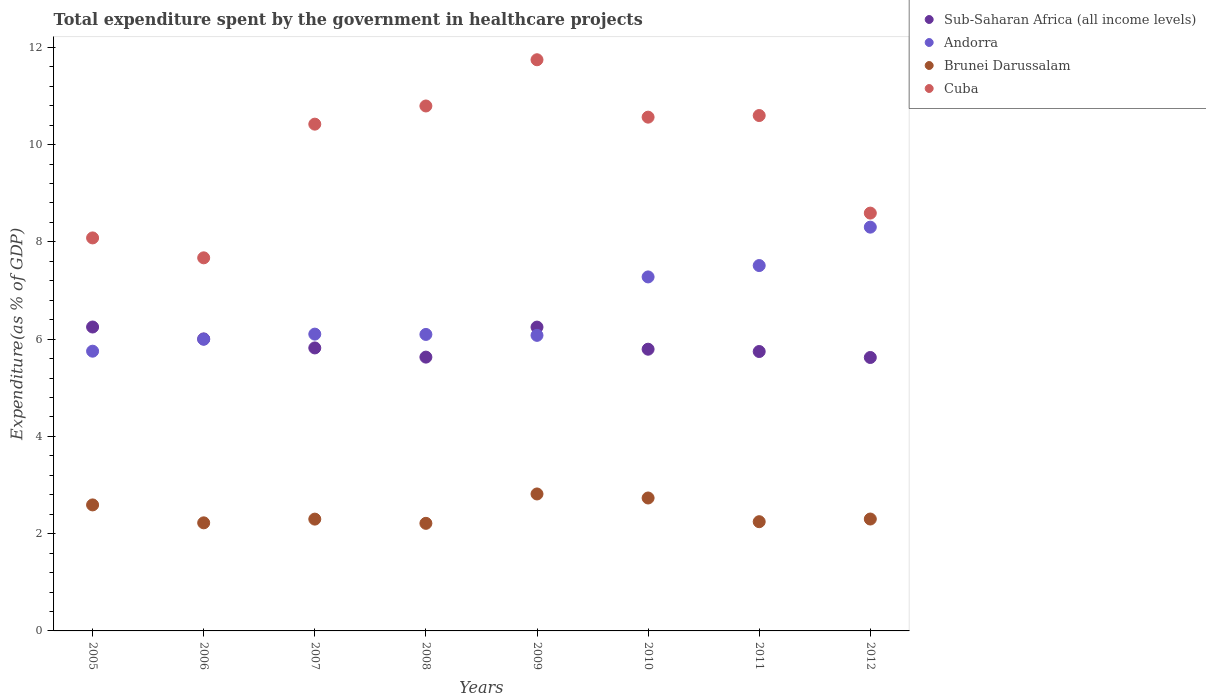How many different coloured dotlines are there?
Offer a very short reply. 4. What is the total expenditure spent by the government in healthcare projects in Brunei Darussalam in 2005?
Ensure brevity in your answer.  2.59. Across all years, what is the maximum total expenditure spent by the government in healthcare projects in Cuba?
Provide a succinct answer. 11.74. Across all years, what is the minimum total expenditure spent by the government in healthcare projects in Brunei Darussalam?
Your answer should be very brief. 2.21. In which year was the total expenditure spent by the government in healthcare projects in Cuba minimum?
Your answer should be compact. 2006. What is the total total expenditure spent by the government in healthcare projects in Cuba in the graph?
Your answer should be compact. 78.46. What is the difference between the total expenditure spent by the government in healthcare projects in Brunei Darussalam in 2007 and that in 2010?
Provide a succinct answer. -0.43. What is the difference between the total expenditure spent by the government in healthcare projects in Cuba in 2011 and the total expenditure spent by the government in healthcare projects in Sub-Saharan Africa (all income levels) in 2010?
Ensure brevity in your answer.  4.8. What is the average total expenditure spent by the government in healthcare projects in Brunei Darussalam per year?
Offer a terse response. 2.43. In the year 2006, what is the difference between the total expenditure spent by the government in healthcare projects in Sub-Saharan Africa (all income levels) and total expenditure spent by the government in healthcare projects in Brunei Darussalam?
Make the answer very short. 3.78. What is the ratio of the total expenditure spent by the government in healthcare projects in Andorra in 2005 to that in 2011?
Provide a succinct answer. 0.77. Is the difference between the total expenditure spent by the government in healthcare projects in Sub-Saharan Africa (all income levels) in 2005 and 2012 greater than the difference between the total expenditure spent by the government in healthcare projects in Brunei Darussalam in 2005 and 2012?
Ensure brevity in your answer.  Yes. What is the difference between the highest and the second highest total expenditure spent by the government in healthcare projects in Brunei Darussalam?
Your response must be concise. 0.08. What is the difference between the highest and the lowest total expenditure spent by the government in healthcare projects in Sub-Saharan Africa (all income levels)?
Your response must be concise. 0.63. Is it the case that in every year, the sum of the total expenditure spent by the government in healthcare projects in Andorra and total expenditure spent by the government in healthcare projects in Brunei Darussalam  is greater than the sum of total expenditure spent by the government in healthcare projects in Cuba and total expenditure spent by the government in healthcare projects in Sub-Saharan Africa (all income levels)?
Offer a very short reply. Yes. Is it the case that in every year, the sum of the total expenditure spent by the government in healthcare projects in Sub-Saharan Africa (all income levels) and total expenditure spent by the government in healthcare projects in Cuba  is greater than the total expenditure spent by the government in healthcare projects in Andorra?
Provide a short and direct response. Yes. Is the total expenditure spent by the government in healthcare projects in Andorra strictly greater than the total expenditure spent by the government in healthcare projects in Brunei Darussalam over the years?
Your answer should be very brief. Yes. How many dotlines are there?
Ensure brevity in your answer.  4. How many years are there in the graph?
Your answer should be very brief. 8. What is the difference between two consecutive major ticks on the Y-axis?
Give a very brief answer. 2. Are the values on the major ticks of Y-axis written in scientific E-notation?
Provide a succinct answer. No. Where does the legend appear in the graph?
Ensure brevity in your answer.  Top right. What is the title of the graph?
Provide a short and direct response. Total expenditure spent by the government in healthcare projects. What is the label or title of the Y-axis?
Provide a succinct answer. Expenditure(as % of GDP). What is the Expenditure(as % of GDP) of Sub-Saharan Africa (all income levels) in 2005?
Your answer should be compact. 6.25. What is the Expenditure(as % of GDP) of Andorra in 2005?
Keep it short and to the point. 5.75. What is the Expenditure(as % of GDP) in Brunei Darussalam in 2005?
Offer a very short reply. 2.59. What is the Expenditure(as % of GDP) of Cuba in 2005?
Provide a short and direct response. 8.08. What is the Expenditure(as % of GDP) in Sub-Saharan Africa (all income levels) in 2006?
Make the answer very short. 6. What is the Expenditure(as % of GDP) in Andorra in 2006?
Make the answer very short. 6. What is the Expenditure(as % of GDP) in Brunei Darussalam in 2006?
Offer a very short reply. 2.22. What is the Expenditure(as % of GDP) of Cuba in 2006?
Give a very brief answer. 7.67. What is the Expenditure(as % of GDP) in Sub-Saharan Africa (all income levels) in 2007?
Offer a terse response. 5.82. What is the Expenditure(as % of GDP) in Andorra in 2007?
Your response must be concise. 6.1. What is the Expenditure(as % of GDP) of Brunei Darussalam in 2007?
Give a very brief answer. 2.3. What is the Expenditure(as % of GDP) of Cuba in 2007?
Make the answer very short. 10.42. What is the Expenditure(as % of GDP) in Sub-Saharan Africa (all income levels) in 2008?
Ensure brevity in your answer.  5.63. What is the Expenditure(as % of GDP) of Andorra in 2008?
Keep it short and to the point. 6.1. What is the Expenditure(as % of GDP) in Brunei Darussalam in 2008?
Provide a short and direct response. 2.21. What is the Expenditure(as % of GDP) of Cuba in 2008?
Your answer should be compact. 10.79. What is the Expenditure(as % of GDP) of Sub-Saharan Africa (all income levels) in 2009?
Ensure brevity in your answer.  6.25. What is the Expenditure(as % of GDP) of Andorra in 2009?
Your answer should be compact. 6.08. What is the Expenditure(as % of GDP) of Brunei Darussalam in 2009?
Your answer should be compact. 2.82. What is the Expenditure(as % of GDP) of Cuba in 2009?
Your response must be concise. 11.74. What is the Expenditure(as % of GDP) of Sub-Saharan Africa (all income levels) in 2010?
Provide a succinct answer. 5.79. What is the Expenditure(as % of GDP) of Andorra in 2010?
Your answer should be compact. 7.28. What is the Expenditure(as % of GDP) of Brunei Darussalam in 2010?
Ensure brevity in your answer.  2.73. What is the Expenditure(as % of GDP) of Cuba in 2010?
Your answer should be very brief. 10.56. What is the Expenditure(as % of GDP) in Sub-Saharan Africa (all income levels) in 2011?
Offer a terse response. 5.74. What is the Expenditure(as % of GDP) of Andorra in 2011?
Your answer should be compact. 7.51. What is the Expenditure(as % of GDP) of Brunei Darussalam in 2011?
Provide a succinct answer. 2.25. What is the Expenditure(as % of GDP) in Cuba in 2011?
Your answer should be very brief. 10.6. What is the Expenditure(as % of GDP) of Sub-Saharan Africa (all income levels) in 2012?
Offer a very short reply. 5.62. What is the Expenditure(as % of GDP) of Andorra in 2012?
Keep it short and to the point. 8.3. What is the Expenditure(as % of GDP) in Brunei Darussalam in 2012?
Your answer should be compact. 2.3. What is the Expenditure(as % of GDP) in Cuba in 2012?
Provide a succinct answer. 8.59. Across all years, what is the maximum Expenditure(as % of GDP) in Sub-Saharan Africa (all income levels)?
Provide a succinct answer. 6.25. Across all years, what is the maximum Expenditure(as % of GDP) of Andorra?
Offer a terse response. 8.3. Across all years, what is the maximum Expenditure(as % of GDP) in Brunei Darussalam?
Make the answer very short. 2.82. Across all years, what is the maximum Expenditure(as % of GDP) of Cuba?
Make the answer very short. 11.74. Across all years, what is the minimum Expenditure(as % of GDP) in Sub-Saharan Africa (all income levels)?
Offer a very short reply. 5.62. Across all years, what is the minimum Expenditure(as % of GDP) of Andorra?
Your response must be concise. 5.75. Across all years, what is the minimum Expenditure(as % of GDP) of Brunei Darussalam?
Give a very brief answer. 2.21. Across all years, what is the minimum Expenditure(as % of GDP) in Cuba?
Keep it short and to the point. 7.67. What is the total Expenditure(as % of GDP) of Sub-Saharan Africa (all income levels) in the graph?
Your answer should be compact. 47.11. What is the total Expenditure(as % of GDP) of Andorra in the graph?
Give a very brief answer. 53.12. What is the total Expenditure(as % of GDP) of Brunei Darussalam in the graph?
Offer a very short reply. 19.42. What is the total Expenditure(as % of GDP) in Cuba in the graph?
Your answer should be compact. 78.46. What is the difference between the Expenditure(as % of GDP) in Sub-Saharan Africa (all income levels) in 2005 and that in 2006?
Ensure brevity in your answer.  0.24. What is the difference between the Expenditure(as % of GDP) in Andorra in 2005 and that in 2006?
Offer a very short reply. -0.25. What is the difference between the Expenditure(as % of GDP) in Brunei Darussalam in 2005 and that in 2006?
Your answer should be very brief. 0.37. What is the difference between the Expenditure(as % of GDP) of Cuba in 2005 and that in 2006?
Offer a very short reply. 0.41. What is the difference between the Expenditure(as % of GDP) in Sub-Saharan Africa (all income levels) in 2005 and that in 2007?
Your answer should be compact. 0.43. What is the difference between the Expenditure(as % of GDP) in Andorra in 2005 and that in 2007?
Make the answer very short. -0.35. What is the difference between the Expenditure(as % of GDP) of Brunei Darussalam in 2005 and that in 2007?
Make the answer very short. 0.29. What is the difference between the Expenditure(as % of GDP) in Cuba in 2005 and that in 2007?
Your answer should be compact. -2.34. What is the difference between the Expenditure(as % of GDP) in Sub-Saharan Africa (all income levels) in 2005 and that in 2008?
Your answer should be compact. 0.62. What is the difference between the Expenditure(as % of GDP) in Andorra in 2005 and that in 2008?
Ensure brevity in your answer.  -0.34. What is the difference between the Expenditure(as % of GDP) in Brunei Darussalam in 2005 and that in 2008?
Make the answer very short. 0.38. What is the difference between the Expenditure(as % of GDP) of Cuba in 2005 and that in 2008?
Make the answer very short. -2.71. What is the difference between the Expenditure(as % of GDP) of Sub-Saharan Africa (all income levels) in 2005 and that in 2009?
Offer a terse response. 0. What is the difference between the Expenditure(as % of GDP) in Andorra in 2005 and that in 2009?
Your answer should be very brief. -0.33. What is the difference between the Expenditure(as % of GDP) of Brunei Darussalam in 2005 and that in 2009?
Your answer should be compact. -0.23. What is the difference between the Expenditure(as % of GDP) of Cuba in 2005 and that in 2009?
Offer a terse response. -3.66. What is the difference between the Expenditure(as % of GDP) of Sub-Saharan Africa (all income levels) in 2005 and that in 2010?
Your answer should be compact. 0.46. What is the difference between the Expenditure(as % of GDP) of Andorra in 2005 and that in 2010?
Offer a very short reply. -1.53. What is the difference between the Expenditure(as % of GDP) in Brunei Darussalam in 2005 and that in 2010?
Offer a terse response. -0.14. What is the difference between the Expenditure(as % of GDP) of Cuba in 2005 and that in 2010?
Offer a terse response. -2.48. What is the difference between the Expenditure(as % of GDP) of Sub-Saharan Africa (all income levels) in 2005 and that in 2011?
Your response must be concise. 0.5. What is the difference between the Expenditure(as % of GDP) in Andorra in 2005 and that in 2011?
Your answer should be very brief. -1.76. What is the difference between the Expenditure(as % of GDP) of Brunei Darussalam in 2005 and that in 2011?
Give a very brief answer. 0.35. What is the difference between the Expenditure(as % of GDP) in Cuba in 2005 and that in 2011?
Provide a short and direct response. -2.52. What is the difference between the Expenditure(as % of GDP) in Sub-Saharan Africa (all income levels) in 2005 and that in 2012?
Ensure brevity in your answer.  0.63. What is the difference between the Expenditure(as % of GDP) in Andorra in 2005 and that in 2012?
Provide a succinct answer. -2.55. What is the difference between the Expenditure(as % of GDP) of Brunei Darussalam in 2005 and that in 2012?
Make the answer very short. 0.29. What is the difference between the Expenditure(as % of GDP) in Cuba in 2005 and that in 2012?
Provide a short and direct response. -0.51. What is the difference between the Expenditure(as % of GDP) of Sub-Saharan Africa (all income levels) in 2006 and that in 2007?
Give a very brief answer. 0.19. What is the difference between the Expenditure(as % of GDP) of Andorra in 2006 and that in 2007?
Ensure brevity in your answer.  -0.11. What is the difference between the Expenditure(as % of GDP) in Brunei Darussalam in 2006 and that in 2007?
Keep it short and to the point. -0.08. What is the difference between the Expenditure(as % of GDP) of Cuba in 2006 and that in 2007?
Provide a succinct answer. -2.75. What is the difference between the Expenditure(as % of GDP) in Sub-Saharan Africa (all income levels) in 2006 and that in 2008?
Offer a very short reply. 0.37. What is the difference between the Expenditure(as % of GDP) in Andorra in 2006 and that in 2008?
Your answer should be compact. -0.1. What is the difference between the Expenditure(as % of GDP) of Brunei Darussalam in 2006 and that in 2008?
Your response must be concise. 0.01. What is the difference between the Expenditure(as % of GDP) in Cuba in 2006 and that in 2008?
Your response must be concise. -3.12. What is the difference between the Expenditure(as % of GDP) in Sub-Saharan Africa (all income levels) in 2006 and that in 2009?
Offer a very short reply. -0.24. What is the difference between the Expenditure(as % of GDP) in Andorra in 2006 and that in 2009?
Your response must be concise. -0.08. What is the difference between the Expenditure(as % of GDP) in Brunei Darussalam in 2006 and that in 2009?
Keep it short and to the point. -0.59. What is the difference between the Expenditure(as % of GDP) of Cuba in 2006 and that in 2009?
Make the answer very short. -4.07. What is the difference between the Expenditure(as % of GDP) of Sub-Saharan Africa (all income levels) in 2006 and that in 2010?
Your answer should be very brief. 0.21. What is the difference between the Expenditure(as % of GDP) of Andorra in 2006 and that in 2010?
Ensure brevity in your answer.  -1.28. What is the difference between the Expenditure(as % of GDP) in Brunei Darussalam in 2006 and that in 2010?
Your answer should be very brief. -0.51. What is the difference between the Expenditure(as % of GDP) in Cuba in 2006 and that in 2010?
Offer a very short reply. -2.89. What is the difference between the Expenditure(as % of GDP) of Sub-Saharan Africa (all income levels) in 2006 and that in 2011?
Your answer should be very brief. 0.26. What is the difference between the Expenditure(as % of GDP) in Andorra in 2006 and that in 2011?
Give a very brief answer. -1.52. What is the difference between the Expenditure(as % of GDP) of Brunei Darussalam in 2006 and that in 2011?
Ensure brevity in your answer.  -0.02. What is the difference between the Expenditure(as % of GDP) of Cuba in 2006 and that in 2011?
Give a very brief answer. -2.93. What is the difference between the Expenditure(as % of GDP) of Sub-Saharan Africa (all income levels) in 2006 and that in 2012?
Give a very brief answer. 0.38. What is the difference between the Expenditure(as % of GDP) in Andorra in 2006 and that in 2012?
Ensure brevity in your answer.  -2.31. What is the difference between the Expenditure(as % of GDP) of Brunei Darussalam in 2006 and that in 2012?
Provide a succinct answer. -0.08. What is the difference between the Expenditure(as % of GDP) in Cuba in 2006 and that in 2012?
Your answer should be compact. -0.92. What is the difference between the Expenditure(as % of GDP) in Sub-Saharan Africa (all income levels) in 2007 and that in 2008?
Keep it short and to the point. 0.19. What is the difference between the Expenditure(as % of GDP) of Andorra in 2007 and that in 2008?
Ensure brevity in your answer.  0.01. What is the difference between the Expenditure(as % of GDP) in Brunei Darussalam in 2007 and that in 2008?
Keep it short and to the point. 0.09. What is the difference between the Expenditure(as % of GDP) of Cuba in 2007 and that in 2008?
Make the answer very short. -0.37. What is the difference between the Expenditure(as % of GDP) of Sub-Saharan Africa (all income levels) in 2007 and that in 2009?
Provide a short and direct response. -0.43. What is the difference between the Expenditure(as % of GDP) of Andorra in 2007 and that in 2009?
Ensure brevity in your answer.  0.03. What is the difference between the Expenditure(as % of GDP) of Brunei Darussalam in 2007 and that in 2009?
Give a very brief answer. -0.52. What is the difference between the Expenditure(as % of GDP) of Cuba in 2007 and that in 2009?
Offer a terse response. -1.32. What is the difference between the Expenditure(as % of GDP) of Sub-Saharan Africa (all income levels) in 2007 and that in 2010?
Provide a succinct answer. 0.03. What is the difference between the Expenditure(as % of GDP) of Andorra in 2007 and that in 2010?
Provide a short and direct response. -1.18. What is the difference between the Expenditure(as % of GDP) of Brunei Darussalam in 2007 and that in 2010?
Provide a short and direct response. -0.43. What is the difference between the Expenditure(as % of GDP) of Cuba in 2007 and that in 2010?
Your answer should be very brief. -0.14. What is the difference between the Expenditure(as % of GDP) in Sub-Saharan Africa (all income levels) in 2007 and that in 2011?
Provide a short and direct response. 0.07. What is the difference between the Expenditure(as % of GDP) in Andorra in 2007 and that in 2011?
Your answer should be compact. -1.41. What is the difference between the Expenditure(as % of GDP) of Brunei Darussalam in 2007 and that in 2011?
Your answer should be very brief. 0.05. What is the difference between the Expenditure(as % of GDP) of Cuba in 2007 and that in 2011?
Provide a short and direct response. -0.18. What is the difference between the Expenditure(as % of GDP) in Sub-Saharan Africa (all income levels) in 2007 and that in 2012?
Ensure brevity in your answer.  0.2. What is the difference between the Expenditure(as % of GDP) of Andorra in 2007 and that in 2012?
Offer a terse response. -2.2. What is the difference between the Expenditure(as % of GDP) in Brunei Darussalam in 2007 and that in 2012?
Ensure brevity in your answer.  -0. What is the difference between the Expenditure(as % of GDP) in Cuba in 2007 and that in 2012?
Make the answer very short. 1.83. What is the difference between the Expenditure(as % of GDP) of Sub-Saharan Africa (all income levels) in 2008 and that in 2009?
Offer a very short reply. -0.62. What is the difference between the Expenditure(as % of GDP) of Andorra in 2008 and that in 2009?
Your answer should be compact. 0.02. What is the difference between the Expenditure(as % of GDP) of Brunei Darussalam in 2008 and that in 2009?
Offer a terse response. -0.6. What is the difference between the Expenditure(as % of GDP) in Cuba in 2008 and that in 2009?
Your response must be concise. -0.95. What is the difference between the Expenditure(as % of GDP) of Sub-Saharan Africa (all income levels) in 2008 and that in 2010?
Keep it short and to the point. -0.16. What is the difference between the Expenditure(as % of GDP) of Andorra in 2008 and that in 2010?
Keep it short and to the point. -1.18. What is the difference between the Expenditure(as % of GDP) in Brunei Darussalam in 2008 and that in 2010?
Your response must be concise. -0.52. What is the difference between the Expenditure(as % of GDP) of Cuba in 2008 and that in 2010?
Give a very brief answer. 0.23. What is the difference between the Expenditure(as % of GDP) in Sub-Saharan Africa (all income levels) in 2008 and that in 2011?
Offer a very short reply. -0.12. What is the difference between the Expenditure(as % of GDP) in Andorra in 2008 and that in 2011?
Your answer should be very brief. -1.42. What is the difference between the Expenditure(as % of GDP) in Brunei Darussalam in 2008 and that in 2011?
Your answer should be compact. -0.03. What is the difference between the Expenditure(as % of GDP) in Cuba in 2008 and that in 2011?
Provide a short and direct response. 0.2. What is the difference between the Expenditure(as % of GDP) in Sub-Saharan Africa (all income levels) in 2008 and that in 2012?
Offer a terse response. 0.01. What is the difference between the Expenditure(as % of GDP) of Andorra in 2008 and that in 2012?
Keep it short and to the point. -2.21. What is the difference between the Expenditure(as % of GDP) in Brunei Darussalam in 2008 and that in 2012?
Your response must be concise. -0.09. What is the difference between the Expenditure(as % of GDP) in Cuba in 2008 and that in 2012?
Make the answer very short. 2.2. What is the difference between the Expenditure(as % of GDP) of Sub-Saharan Africa (all income levels) in 2009 and that in 2010?
Give a very brief answer. 0.45. What is the difference between the Expenditure(as % of GDP) in Andorra in 2009 and that in 2010?
Offer a terse response. -1.2. What is the difference between the Expenditure(as % of GDP) in Brunei Darussalam in 2009 and that in 2010?
Give a very brief answer. 0.08. What is the difference between the Expenditure(as % of GDP) of Cuba in 2009 and that in 2010?
Offer a very short reply. 1.18. What is the difference between the Expenditure(as % of GDP) of Sub-Saharan Africa (all income levels) in 2009 and that in 2011?
Provide a short and direct response. 0.5. What is the difference between the Expenditure(as % of GDP) of Andorra in 2009 and that in 2011?
Ensure brevity in your answer.  -1.44. What is the difference between the Expenditure(as % of GDP) in Brunei Darussalam in 2009 and that in 2011?
Your response must be concise. 0.57. What is the difference between the Expenditure(as % of GDP) of Cuba in 2009 and that in 2011?
Keep it short and to the point. 1.15. What is the difference between the Expenditure(as % of GDP) in Sub-Saharan Africa (all income levels) in 2009 and that in 2012?
Provide a succinct answer. 0.62. What is the difference between the Expenditure(as % of GDP) of Andorra in 2009 and that in 2012?
Your answer should be very brief. -2.22. What is the difference between the Expenditure(as % of GDP) in Brunei Darussalam in 2009 and that in 2012?
Make the answer very short. 0.52. What is the difference between the Expenditure(as % of GDP) of Cuba in 2009 and that in 2012?
Provide a succinct answer. 3.15. What is the difference between the Expenditure(as % of GDP) in Sub-Saharan Africa (all income levels) in 2010 and that in 2011?
Give a very brief answer. 0.05. What is the difference between the Expenditure(as % of GDP) of Andorra in 2010 and that in 2011?
Ensure brevity in your answer.  -0.23. What is the difference between the Expenditure(as % of GDP) of Brunei Darussalam in 2010 and that in 2011?
Ensure brevity in your answer.  0.49. What is the difference between the Expenditure(as % of GDP) of Cuba in 2010 and that in 2011?
Your response must be concise. -0.03. What is the difference between the Expenditure(as % of GDP) of Sub-Saharan Africa (all income levels) in 2010 and that in 2012?
Your answer should be compact. 0.17. What is the difference between the Expenditure(as % of GDP) of Andorra in 2010 and that in 2012?
Keep it short and to the point. -1.02. What is the difference between the Expenditure(as % of GDP) in Brunei Darussalam in 2010 and that in 2012?
Your response must be concise. 0.43. What is the difference between the Expenditure(as % of GDP) in Cuba in 2010 and that in 2012?
Keep it short and to the point. 1.97. What is the difference between the Expenditure(as % of GDP) of Sub-Saharan Africa (all income levels) in 2011 and that in 2012?
Offer a very short reply. 0.12. What is the difference between the Expenditure(as % of GDP) of Andorra in 2011 and that in 2012?
Provide a short and direct response. -0.79. What is the difference between the Expenditure(as % of GDP) of Brunei Darussalam in 2011 and that in 2012?
Make the answer very short. -0.05. What is the difference between the Expenditure(as % of GDP) of Cuba in 2011 and that in 2012?
Make the answer very short. 2.01. What is the difference between the Expenditure(as % of GDP) in Sub-Saharan Africa (all income levels) in 2005 and the Expenditure(as % of GDP) in Andorra in 2006?
Offer a very short reply. 0.25. What is the difference between the Expenditure(as % of GDP) of Sub-Saharan Africa (all income levels) in 2005 and the Expenditure(as % of GDP) of Brunei Darussalam in 2006?
Provide a short and direct response. 4.03. What is the difference between the Expenditure(as % of GDP) in Sub-Saharan Africa (all income levels) in 2005 and the Expenditure(as % of GDP) in Cuba in 2006?
Provide a short and direct response. -1.42. What is the difference between the Expenditure(as % of GDP) in Andorra in 2005 and the Expenditure(as % of GDP) in Brunei Darussalam in 2006?
Provide a succinct answer. 3.53. What is the difference between the Expenditure(as % of GDP) in Andorra in 2005 and the Expenditure(as % of GDP) in Cuba in 2006?
Your answer should be very brief. -1.92. What is the difference between the Expenditure(as % of GDP) of Brunei Darussalam in 2005 and the Expenditure(as % of GDP) of Cuba in 2006?
Keep it short and to the point. -5.08. What is the difference between the Expenditure(as % of GDP) of Sub-Saharan Africa (all income levels) in 2005 and the Expenditure(as % of GDP) of Andorra in 2007?
Your response must be concise. 0.15. What is the difference between the Expenditure(as % of GDP) of Sub-Saharan Africa (all income levels) in 2005 and the Expenditure(as % of GDP) of Brunei Darussalam in 2007?
Ensure brevity in your answer.  3.95. What is the difference between the Expenditure(as % of GDP) in Sub-Saharan Africa (all income levels) in 2005 and the Expenditure(as % of GDP) in Cuba in 2007?
Give a very brief answer. -4.17. What is the difference between the Expenditure(as % of GDP) of Andorra in 2005 and the Expenditure(as % of GDP) of Brunei Darussalam in 2007?
Offer a terse response. 3.45. What is the difference between the Expenditure(as % of GDP) in Andorra in 2005 and the Expenditure(as % of GDP) in Cuba in 2007?
Offer a terse response. -4.67. What is the difference between the Expenditure(as % of GDP) in Brunei Darussalam in 2005 and the Expenditure(as % of GDP) in Cuba in 2007?
Your response must be concise. -7.83. What is the difference between the Expenditure(as % of GDP) in Sub-Saharan Africa (all income levels) in 2005 and the Expenditure(as % of GDP) in Andorra in 2008?
Your answer should be compact. 0.15. What is the difference between the Expenditure(as % of GDP) in Sub-Saharan Africa (all income levels) in 2005 and the Expenditure(as % of GDP) in Brunei Darussalam in 2008?
Your answer should be compact. 4.04. What is the difference between the Expenditure(as % of GDP) in Sub-Saharan Africa (all income levels) in 2005 and the Expenditure(as % of GDP) in Cuba in 2008?
Provide a short and direct response. -4.54. What is the difference between the Expenditure(as % of GDP) of Andorra in 2005 and the Expenditure(as % of GDP) of Brunei Darussalam in 2008?
Provide a succinct answer. 3.54. What is the difference between the Expenditure(as % of GDP) in Andorra in 2005 and the Expenditure(as % of GDP) in Cuba in 2008?
Your answer should be very brief. -5.04. What is the difference between the Expenditure(as % of GDP) in Brunei Darussalam in 2005 and the Expenditure(as % of GDP) in Cuba in 2008?
Offer a terse response. -8.2. What is the difference between the Expenditure(as % of GDP) in Sub-Saharan Africa (all income levels) in 2005 and the Expenditure(as % of GDP) in Andorra in 2009?
Ensure brevity in your answer.  0.17. What is the difference between the Expenditure(as % of GDP) of Sub-Saharan Africa (all income levels) in 2005 and the Expenditure(as % of GDP) of Brunei Darussalam in 2009?
Your response must be concise. 3.43. What is the difference between the Expenditure(as % of GDP) in Sub-Saharan Africa (all income levels) in 2005 and the Expenditure(as % of GDP) in Cuba in 2009?
Make the answer very short. -5.5. What is the difference between the Expenditure(as % of GDP) in Andorra in 2005 and the Expenditure(as % of GDP) in Brunei Darussalam in 2009?
Keep it short and to the point. 2.94. What is the difference between the Expenditure(as % of GDP) in Andorra in 2005 and the Expenditure(as % of GDP) in Cuba in 2009?
Your response must be concise. -5.99. What is the difference between the Expenditure(as % of GDP) in Brunei Darussalam in 2005 and the Expenditure(as % of GDP) in Cuba in 2009?
Provide a succinct answer. -9.15. What is the difference between the Expenditure(as % of GDP) of Sub-Saharan Africa (all income levels) in 2005 and the Expenditure(as % of GDP) of Andorra in 2010?
Ensure brevity in your answer.  -1.03. What is the difference between the Expenditure(as % of GDP) of Sub-Saharan Africa (all income levels) in 2005 and the Expenditure(as % of GDP) of Brunei Darussalam in 2010?
Give a very brief answer. 3.52. What is the difference between the Expenditure(as % of GDP) of Sub-Saharan Africa (all income levels) in 2005 and the Expenditure(as % of GDP) of Cuba in 2010?
Make the answer very short. -4.31. What is the difference between the Expenditure(as % of GDP) in Andorra in 2005 and the Expenditure(as % of GDP) in Brunei Darussalam in 2010?
Ensure brevity in your answer.  3.02. What is the difference between the Expenditure(as % of GDP) in Andorra in 2005 and the Expenditure(as % of GDP) in Cuba in 2010?
Your answer should be very brief. -4.81. What is the difference between the Expenditure(as % of GDP) in Brunei Darussalam in 2005 and the Expenditure(as % of GDP) in Cuba in 2010?
Keep it short and to the point. -7.97. What is the difference between the Expenditure(as % of GDP) of Sub-Saharan Africa (all income levels) in 2005 and the Expenditure(as % of GDP) of Andorra in 2011?
Give a very brief answer. -1.26. What is the difference between the Expenditure(as % of GDP) of Sub-Saharan Africa (all income levels) in 2005 and the Expenditure(as % of GDP) of Brunei Darussalam in 2011?
Give a very brief answer. 4. What is the difference between the Expenditure(as % of GDP) of Sub-Saharan Africa (all income levels) in 2005 and the Expenditure(as % of GDP) of Cuba in 2011?
Offer a very short reply. -4.35. What is the difference between the Expenditure(as % of GDP) of Andorra in 2005 and the Expenditure(as % of GDP) of Brunei Darussalam in 2011?
Provide a short and direct response. 3.51. What is the difference between the Expenditure(as % of GDP) in Andorra in 2005 and the Expenditure(as % of GDP) in Cuba in 2011?
Keep it short and to the point. -4.85. What is the difference between the Expenditure(as % of GDP) of Brunei Darussalam in 2005 and the Expenditure(as % of GDP) of Cuba in 2011?
Give a very brief answer. -8.01. What is the difference between the Expenditure(as % of GDP) in Sub-Saharan Africa (all income levels) in 2005 and the Expenditure(as % of GDP) in Andorra in 2012?
Your response must be concise. -2.05. What is the difference between the Expenditure(as % of GDP) in Sub-Saharan Africa (all income levels) in 2005 and the Expenditure(as % of GDP) in Brunei Darussalam in 2012?
Provide a succinct answer. 3.95. What is the difference between the Expenditure(as % of GDP) of Sub-Saharan Africa (all income levels) in 2005 and the Expenditure(as % of GDP) of Cuba in 2012?
Provide a short and direct response. -2.34. What is the difference between the Expenditure(as % of GDP) of Andorra in 2005 and the Expenditure(as % of GDP) of Brunei Darussalam in 2012?
Provide a short and direct response. 3.45. What is the difference between the Expenditure(as % of GDP) of Andorra in 2005 and the Expenditure(as % of GDP) of Cuba in 2012?
Your answer should be very brief. -2.84. What is the difference between the Expenditure(as % of GDP) of Brunei Darussalam in 2005 and the Expenditure(as % of GDP) of Cuba in 2012?
Your answer should be compact. -6. What is the difference between the Expenditure(as % of GDP) in Sub-Saharan Africa (all income levels) in 2006 and the Expenditure(as % of GDP) in Andorra in 2007?
Your answer should be very brief. -0.1. What is the difference between the Expenditure(as % of GDP) of Sub-Saharan Africa (all income levels) in 2006 and the Expenditure(as % of GDP) of Brunei Darussalam in 2007?
Give a very brief answer. 3.71. What is the difference between the Expenditure(as % of GDP) in Sub-Saharan Africa (all income levels) in 2006 and the Expenditure(as % of GDP) in Cuba in 2007?
Make the answer very short. -4.42. What is the difference between the Expenditure(as % of GDP) of Andorra in 2006 and the Expenditure(as % of GDP) of Brunei Darussalam in 2007?
Offer a very short reply. 3.7. What is the difference between the Expenditure(as % of GDP) of Andorra in 2006 and the Expenditure(as % of GDP) of Cuba in 2007?
Keep it short and to the point. -4.42. What is the difference between the Expenditure(as % of GDP) in Brunei Darussalam in 2006 and the Expenditure(as % of GDP) in Cuba in 2007?
Keep it short and to the point. -8.2. What is the difference between the Expenditure(as % of GDP) in Sub-Saharan Africa (all income levels) in 2006 and the Expenditure(as % of GDP) in Andorra in 2008?
Your answer should be very brief. -0.09. What is the difference between the Expenditure(as % of GDP) of Sub-Saharan Africa (all income levels) in 2006 and the Expenditure(as % of GDP) of Brunei Darussalam in 2008?
Your response must be concise. 3.79. What is the difference between the Expenditure(as % of GDP) of Sub-Saharan Africa (all income levels) in 2006 and the Expenditure(as % of GDP) of Cuba in 2008?
Keep it short and to the point. -4.79. What is the difference between the Expenditure(as % of GDP) in Andorra in 2006 and the Expenditure(as % of GDP) in Brunei Darussalam in 2008?
Your answer should be compact. 3.78. What is the difference between the Expenditure(as % of GDP) in Andorra in 2006 and the Expenditure(as % of GDP) in Cuba in 2008?
Provide a succinct answer. -4.8. What is the difference between the Expenditure(as % of GDP) in Brunei Darussalam in 2006 and the Expenditure(as % of GDP) in Cuba in 2008?
Your response must be concise. -8.57. What is the difference between the Expenditure(as % of GDP) of Sub-Saharan Africa (all income levels) in 2006 and the Expenditure(as % of GDP) of Andorra in 2009?
Offer a very short reply. -0.07. What is the difference between the Expenditure(as % of GDP) in Sub-Saharan Africa (all income levels) in 2006 and the Expenditure(as % of GDP) in Brunei Darussalam in 2009?
Your response must be concise. 3.19. What is the difference between the Expenditure(as % of GDP) in Sub-Saharan Africa (all income levels) in 2006 and the Expenditure(as % of GDP) in Cuba in 2009?
Your answer should be compact. -5.74. What is the difference between the Expenditure(as % of GDP) in Andorra in 2006 and the Expenditure(as % of GDP) in Brunei Darussalam in 2009?
Keep it short and to the point. 3.18. What is the difference between the Expenditure(as % of GDP) of Andorra in 2006 and the Expenditure(as % of GDP) of Cuba in 2009?
Your answer should be very brief. -5.75. What is the difference between the Expenditure(as % of GDP) in Brunei Darussalam in 2006 and the Expenditure(as % of GDP) in Cuba in 2009?
Give a very brief answer. -9.52. What is the difference between the Expenditure(as % of GDP) of Sub-Saharan Africa (all income levels) in 2006 and the Expenditure(as % of GDP) of Andorra in 2010?
Provide a succinct answer. -1.27. What is the difference between the Expenditure(as % of GDP) of Sub-Saharan Africa (all income levels) in 2006 and the Expenditure(as % of GDP) of Brunei Darussalam in 2010?
Provide a succinct answer. 3.27. What is the difference between the Expenditure(as % of GDP) in Sub-Saharan Africa (all income levels) in 2006 and the Expenditure(as % of GDP) in Cuba in 2010?
Give a very brief answer. -4.56. What is the difference between the Expenditure(as % of GDP) of Andorra in 2006 and the Expenditure(as % of GDP) of Brunei Darussalam in 2010?
Offer a very short reply. 3.26. What is the difference between the Expenditure(as % of GDP) of Andorra in 2006 and the Expenditure(as % of GDP) of Cuba in 2010?
Provide a succinct answer. -4.57. What is the difference between the Expenditure(as % of GDP) of Brunei Darussalam in 2006 and the Expenditure(as % of GDP) of Cuba in 2010?
Keep it short and to the point. -8.34. What is the difference between the Expenditure(as % of GDP) of Sub-Saharan Africa (all income levels) in 2006 and the Expenditure(as % of GDP) of Andorra in 2011?
Ensure brevity in your answer.  -1.51. What is the difference between the Expenditure(as % of GDP) in Sub-Saharan Africa (all income levels) in 2006 and the Expenditure(as % of GDP) in Brunei Darussalam in 2011?
Ensure brevity in your answer.  3.76. What is the difference between the Expenditure(as % of GDP) of Sub-Saharan Africa (all income levels) in 2006 and the Expenditure(as % of GDP) of Cuba in 2011?
Make the answer very short. -4.59. What is the difference between the Expenditure(as % of GDP) in Andorra in 2006 and the Expenditure(as % of GDP) in Brunei Darussalam in 2011?
Your answer should be compact. 3.75. What is the difference between the Expenditure(as % of GDP) of Andorra in 2006 and the Expenditure(as % of GDP) of Cuba in 2011?
Make the answer very short. -4.6. What is the difference between the Expenditure(as % of GDP) in Brunei Darussalam in 2006 and the Expenditure(as % of GDP) in Cuba in 2011?
Your response must be concise. -8.37. What is the difference between the Expenditure(as % of GDP) in Sub-Saharan Africa (all income levels) in 2006 and the Expenditure(as % of GDP) in Andorra in 2012?
Your answer should be very brief. -2.3. What is the difference between the Expenditure(as % of GDP) of Sub-Saharan Africa (all income levels) in 2006 and the Expenditure(as % of GDP) of Brunei Darussalam in 2012?
Offer a very short reply. 3.7. What is the difference between the Expenditure(as % of GDP) in Sub-Saharan Africa (all income levels) in 2006 and the Expenditure(as % of GDP) in Cuba in 2012?
Provide a succinct answer. -2.59. What is the difference between the Expenditure(as % of GDP) in Andorra in 2006 and the Expenditure(as % of GDP) in Brunei Darussalam in 2012?
Ensure brevity in your answer.  3.7. What is the difference between the Expenditure(as % of GDP) of Andorra in 2006 and the Expenditure(as % of GDP) of Cuba in 2012?
Offer a terse response. -2.59. What is the difference between the Expenditure(as % of GDP) in Brunei Darussalam in 2006 and the Expenditure(as % of GDP) in Cuba in 2012?
Your response must be concise. -6.37. What is the difference between the Expenditure(as % of GDP) of Sub-Saharan Africa (all income levels) in 2007 and the Expenditure(as % of GDP) of Andorra in 2008?
Keep it short and to the point. -0.28. What is the difference between the Expenditure(as % of GDP) in Sub-Saharan Africa (all income levels) in 2007 and the Expenditure(as % of GDP) in Brunei Darussalam in 2008?
Keep it short and to the point. 3.61. What is the difference between the Expenditure(as % of GDP) of Sub-Saharan Africa (all income levels) in 2007 and the Expenditure(as % of GDP) of Cuba in 2008?
Provide a short and direct response. -4.97. What is the difference between the Expenditure(as % of GDP) of Andorra in 2007 and the Expenditure(as % of GDP) of Brunei Darussalam in 2008?
Your answer should be compact. 3.89. What is the difference between the Expenditure(as % of GDP) in Andorra in 2007 and the Expenditure(as % of GDP) in Cuba in 2008?
Provide a short and direct response. -4.69. What is the difference between the Expenditure(as % of GDP) in Brunei Darussalam in 2007 and the Expenditure(as % of GDP) in Cuba in 2008?
Make the answer very short. -8.49. What is the difference between the Expenditure(as % of GDP) in Sub-Saharan Africa (all income levels) in 2007 and the Expenditure(as % of GDP) in Andorra in 2009?
Ensure brevity in your answer.  -0.26. What is the difference between the Expenditure(as % of GDP) of Sub-Saharan Africa (all income levels) in 2007 and the Expenditure(as % of GDP) of Brunei Darussalam in 2009?
Provide a succinct answer. 3. What is the difference between the Expenditure(as % of GDP) in Sub-Saharan Africa (all income levels) in 2007 and the Expenditure(as % of GDP) in Cuba in 2009?
Provide a short and direct response. -5.93. What is the difference between the Expenditure(as % of GDP) in Andorra in 2007 and the Expenditure(as % of GDP) in Brunei Darussalam in 2009?
Offer a very short reply. 3.29. What is the difference between the Expenditure(as % of GDP) of Andorra in 2007 and the Expenditure(as % of GDP) of Cuba in 2009?
Your answer should be very brief. -5.64. What is the difference between the Expenditure(as % of GDP) in Brunei Darussalam in 2007 and the Expenditure(as % of GDP) in Cuba in 2009?
Provide a succinct answer. -9.45. What is the difference between the Expenditure(as % of GDP) of Sub-Saharan Africa (all income levels) in 2007 and the Expenditure(as % of GDP) of Andorra in 2010?
Your response must be concise. -1.46. What is the difference between the Expenditure(as % of GDP) in Sub-Saharan Africa (all income levels) in 2007 and the Expenditure(as % of GDP) in Brunei Darussalam in 2010?
Provide a short and direct response. 3.09. What is the difference between the Expenditure(as % of GDP) of Sub-Saharan Africa (all income levels) in 2007 and the Expenditure(as % of GDP) of Cuba in 2010?
Keep it short and to the point. -4.75. What is the difference between the Expenditure(as % of GDP) of Andorra in 2007 and the Expenditure(as % of GDP) of Brunei Darussalam in 2010?
Ensure brevity in your answer.  3.37. What is the difference between the Expenditure(as % of GDP) in Andorra in 2007 and the Expenditure(as % of GDP) in Cuba in 2010?
Offer a terse response. -4.46. What is the difference between the Expenditure(as % of GDP) of Brunei Darussalam in 2007 and the Expenditure(as % of GDP) of Cuba in 2010?
Your response must be concise. -8.26. What is the difference between the Expenditure(as % of GDP) in Sub-Saharan Africa (all income levels) in 2007 and the Expenditure(as % of GDP) in Andorra in 2011?
Your answer should be compact. -1.69. What is the difference between the Expenditure(as % of GDP) of Sub-Saharan Africa (all income levels) in 2007 and the Expenditure(as % of GDP) of Brunei Darussalam in 2011?
Your answer should be very brief. 3.57. What is the difference between the Expenditure(as % of GDP) of Sub-Saharan Africa (all income levels) in 2007 and the Expenditure(as % of GDP) of Cuba in 2011?
Keep it short and to the point. -4.78. What is the difference between the Expenditure(as % of GDP) in Andorra in 2007 and the Expenditure(as % of GDP) in Brunei Darussalam in 2011?
Provide a short and direct response. 3.86. What is the difference between the Expenditure(as % of GDP) of Andorra in 2007 and the Expenditure(as % of GDP) of Cuba in 2011?
Offer a terse response. -4.49. What is the difference between the Expenditure(as % of GDP) in Brunei Darussalam in 2007 and the Expenditure(as % of GDP) in Cuba in 2011?
Your answer should be compact. -8.3. What is the difference between the Expenditure(as % of GDP) in Sub-Saharan Africa (all income levels) in 2007 and the Expenditure(as % of GDP) in Andorra in 2012?
Offer a terse response. -2.48. What is the difference between the Expenditure(as % of GDP) in Sub-Saharan Africa (all income levels) in 2007 and the Expenditure(as % of GDP) in Brunei Darussalam in 2012?
Provide a short and direct response. 3.52. What is the difference between the Expenditure(as % of GDP) in Sub-Saharan Africa (all income levels) in 2007 and the Expenditure(as % of GDP) in Cuba in 2012?
Your answer should be compact. -2.77. What is the difference between the Expenditure(as % of GDP) in Andorra in 2007 and the Expenditure(as % of GDP) in Brunei Darussalam in 2012?
Your answer should be very brief. 3.8. What is the difference between the Expenditure(as % of GDP) in Andorra in 2007 and the Expenditure(as % of GDP) in Cuba in 2012?
Offer a terse response. -2.49. What is the difference between the Expenditure(as % of GDP) in Brunei Darussalam in 2007 and the Expenditure(as % of GDP) in Cuba in 2012?
Make the answer very short. -6.29. What is the difference between the Expenditure(as % of GDP) in Sub-Saharan Africa (all income levels) in 2008 and the Expenditure(as % of GDP) in Andorra in 2009?
Make the answer very short. -0.45. What is the difference between the Expenditure(as % of GDP) of Sub-Saharan Africa (all income levels) in 2008 and the Expenditure(as % of GDP) of Brunei Darussalam in 2009?
Give a very brief answer. 2.81. What is the difference between the Expenditure(as % of GDP) in Sub-Saharan Africa (all income levels) in 2008 and the Expenditure(as % of GDP) in Cuba in 2009?
Make the answer very short. -6.11. What is the difference between the Expenditure(as % of GDP) in Andorra in 2008 and the Expenditure(as % of GDP) in Brunei Darussalam in 2009?
Provide a succinct answer. 3.28. What is the difference between the Expenditure(as % of GDP) in Andorra in 2008 and the Expenditure(as % of GDP) in Cuba in 2009?
Your answer should be compact. -5.65. What is the difference between the Expenditure(as % of GDP) of Brunei Darussalam in 2008 and the Expenditure(as % of GDP) of Cuba in 2009?
Offer a very short reply. -9.53. What is the difference between the Expenditure(as % of GDP) in Sub-Saharan Africa (all income levels) in 2008 and the Expenditure(as % of GDP) in Andorra in 2010?
Offer a terse response. -1.65. What is the difference between the Expenditure(as % of GDP) in Sub-Saharan Africa (all income levels) in 2008 and the Expenditure(as % of GDP) in Brunei Darussalam in 2010?
Give a very brief answer. 2.9. What is the difference between the Expenditure(as % of GDP) in Sub-Saharan Africa (all income levels) in 2008 and the Expenditure(as % of GDP) in Cuba in 2010?
Give a very brief answer. -4.93. What is the difference between the Expenditure(as % of GDP) of Andorra in 2008 and the Expenditure(as % of GDP) of Brunei Darussalam in 2010?
Ensure brevity in your answer.  3.36. What is the difference between the Expenditure(as % of GDP) of Andorra in 2008 and the Expenditure(as % of GDP) of Cuba in 2010?
Your response must be concise. -4.47. What is the difference between the Expenditure(as % of GDP) in Brunei Darussalam in 2008 and the Expenditure(as % of GDP) in Cuba in 2010?
Keep it short and to the point. -8.35. What is the difference between the Expenditure(as % of GDP) of Sub-Saharan Africa (all income levels) in 2008 and the Expenditure(as % of GDP) of Andorra in 2011?
Provide a short and direct response. -1.88. What is the difference between the Expenditure(as % of GDP) in Sub-Saharan Africa (all income levels) in 2008 and the Expenditure(as % of GDP) in Brunei Darussalam in 2011?
Your response must be concise. 3.38. What is the difference between the Expenditure(as % of GDP) of Sub-Saharan Africa (all income levels) in 2008 and the Expenditure(as % of GDP) of Cuba in 2011?
Ensure brevity in your answer.  -4.97. What is the difference between the Expenditure(as % of GDP) in Andorra in 2008 and the Expenditure(as % of GDP) in Brunei Darussalam in 2011?
Provide a short and direct response. 3.85. What is the difference between the Expenditure(as % of GDP) of Andorra in 2008 and the Expenditure(as % of GDP) of Cuba in 2011?
Offer a terse response. -4.5. What is the difference between the Expenditure(as % of GDP) of Brunei Darussalam in 2008 and the Expenditure(as % of GDP) of Cuba in 2011?
Give a very brief answer. -8.38. What is the difference between the Expenditure(as % of GDP) in Sub-Saharan Africa (all income levels) in 2008 and the Expenditure(as % of GDP) in Andorra in 2012?
Your response must be concise. -2.67. What is the difference between the Expenditure(as % of GDP) in Sub-Saharan Africa (all income levels) in 2008 and the Expenditure(as % of GDP) in Brunei Darussalam in 2012?
Make the answer very short. 3.33. What is the difference between the Expenditure(as % of GDP) in Sub-Saharan Africa (all income levels) in 2008 and the Expenditure(as % of GDP) in Cuba in 2012?
Offer a very short reply. -2.96. What is the difference between the Expenditure(as % of GDP) of Andorra in 2008 and the Expenditure(as % of GDP) of Brunei Darussalam in 2012?
Offer a very short reply. 3.8. What is the difference between the Expenditure(as % of GDP) in Andorra in 2008 and the Expenditure(as % of GDP) in Cuba in 2012?
Make the answer very short. -2.49. What is the difference between the Expenditure(as % of GDP) in Brunei Darussalam in 2008 and the Expenditure(as % of GDP) in Cuba in 2012?
Make the answer very short. -6.38. What is the difference between the Expenditure(as % of GDP) of Sub-Saharan Africa (all income levels) in 2009 and the Expenditure(as % of GDP) of Andorra in 2010?
Keep it short and to the point. -1.03. What is the difference between the Expenditure(as % of GDP) in Sub-Saharan Africa (all income levels) in 2009 and the Expenditure(as % of GDP) in Brunei Darussalam in 2010?
Provide a short and direct response. 3.51. What is the difference between the Expenditure(as % of GDP) of Sub-Saharan Africa (all income levels) in 2009 and the Expenditure(as % of GDP) of Cuba in 2010?
Provide a succinct answer. -4.32. What is the difference between the Expenditure(as % of GDP) of Andorra in 2009 and the Expenditure(as % of GDP) of Brunei Darussalam in 2010?
Offer a terse response. 3.34. What is the difference between the Expenditure(as % of GDP) of Andorra in 2009 and the Expenditure(as % of GDP) of Cuba in 2010?
Provide a succinct answer. -4.49. What is the difference between the Expenditure(as % of GDP) of Brunei Darussalam in 2009 and the Expenditure(as % of GDP) of Cuba in 2010?
Keep it short and to the point. -7.75. What is the difference between the Expenditure(as % of GDP) of Sub-Saharan Africa (all income levels) in 2009 and the Expenditure(as % of GDP) of Andorra in 2011?
Keep it short and to the point. -1.27. What is the difference between the Expenditure(as % of GDP) of Sub-Saharan Africa (all income levels) in 2009 and the Expenditure(as % of GDP) of Brunei Darussalam in 2011?
Ensure brevity in your answer.  4. What is the difference between the Expenditure(as % of GDP) in Sub-Saharan Africa (all income levels) in 2009 and the Expenditure(as % of GDP) in Cuba in 2011?
Provide a succinct answer. -4.35. What is the difference between the Expenditure(as % of GDP) of Andorra in 2009 and the Expenditure(as % of GDP) of Brunei Darussalam in 2011?
Ensure brevity in your answer.  3.83. What is the difference between the Expenditure(as % of GDP) in Andorra in 2009 and the Expenditure(as % of GDP) in Cuba in 2011?
Your response must be concise. -4.52. What is the difference between the Expenditure(as % of GDP) of Brunei Darussalam in 2009 and the Expenditure(as % of GDP) of Cuba in 2011?
Your answer should be compact. -7.78. What is the difference between the Expenditure(as % of GDP) of Sub-Saharan Africa (all income levels) in 2009 and the Expenditure(as % of GDP) of Andorra in 2012?
Offer a terse response. -2.06. What is the difference between the Expenditure(as % of GDP) of Sub-Saharan Africa (all income levels) in 2009 and the Expenditure(as % of GDP) of Brunei Darussalam in 2012?
Make the answer very short. 3.95. What is the difference between the Expenditure(as % of GDP) of Sub-Saharan Africa (all income levels) in 2009 and the Expenditure(as % of GDP) of Cuba in 2012?
Ensure brevity in your answer.  -2.34. What is the difference between the Expenditure(as % of GDP) in Andorra in 2009 and the Expenditure(as % of GDP) in Brunei Darussalam in 2012?
Offer a terse response. 3.78. What is the difference between the Expenditure(as % of GDP) of Andorra in 2009 and the Expenditure(as % of GDP) of Cuba in 2012?
Your answer should be very brief. -2.51. What is the difference between the Expenditure(as % of GDP) in Brunei Darussalam in 2009 and the Expenditure(as % of GDP) in Cuba in 2012?
Provide a succinct answer. -5.77. What is the difference between the Expenditure(as % of GDP) in Sub-Saharan Africa (all income levels) in 2010 and the Expenditure(as % of GDP) in Andorra in 2011?
Give a very brief answer. -1.72. What is the difference between the Expenditure(as % of GDP) of Sub-Saharan Africa (all income levels) in 2010 and the Expenditure(as % of GDP) of Brunei Darussalam in 2011?
Ensure brevity in your answer.  3.55. What is the difference between the Expenditure(as % of GDP) of Sub-Saharan Africa (all income levels) in 2010 and the Expenditure(as % of GDP) of Cuba in 2011?
Keep it short and to the point. -4.8. What is the difference between the Expenditure(as % of GDP) in Andorra in 2010 and the Expenditure(as % of GDP) in Brunei Darussalam in 2011?
Your answer should be very brief. 5.03. What is the difference between the Expenditure(as % of GDP) of Andorra in 2010 and the Expenditure(as % of GDP) of Cuba in 2011?
Keep it short and to the point. -3.32. What is the difference between the Expenditure(as % of GDP) of Brunei Darussalam in 2010 and the Expenditure(as % of GDP) of Cuba in 2011?
Ensure brevity in your answer.  -7.86. What is the difference between the Expenditure(as % of GDP) of Sub-Saharan Africa (all income levels) in 2010 and the Expenditure(as % of GDP) of Andorra in 2012?
Offer a terse response. -2.51. What is the difference between the Expenditure(as % of GDP) of Sub-Saharan Africa (all income levels) in 2010 and the Expenditure(as % of GDP) of Brunei Darussalam in 2012?
Give a very brief answer. 3.49. What is the difference between the Expenditure(as % of GDP) in Sub-Saharan Africa (all income levels) in 2010 and the Expenditure(as % of GDP) in Cuba in 2012?
Your response must be concise. -2.8. What is the difference between the Expenditure(as % of GDP) in Andorra in 2010 and the Expenditure(as % of GDP) in Brunei Darussalam in 2012?
Your answer should be very brief. 4.98. What is the difference between the Expenditure(as % of GDP) in Andorra in 2010 and the Expenditure(as % of GDP) in Cuba in 2012?
Provide a short and direct response. -1.31. What is the difference between the Expenditure(as % of GDP) of Brunei Darussalam in 2010 and the Expenditure(as % of GDP) of Cuba in 2012?
Make the answer very short. -5.86. What is the difference between the Expenditure(as % of GDP) in Sub-Saharan Africa (all income levels) in 2011 and the Expenditure(as % of GDP) in Andorra in 2012?
Offer a terse response. -2.56. What is the difference between the Expenditure(as % of GDP) of Sub-Saharan Africa (all income levels) in 2011 and the Expenditure(as % of GDP) of Brunei Darussalam in 2012?
Provide a succinct answer. 3.44. What is the difference between the Expenditure(as % of GDP) in Sub-Saharan Africa (all income levels) in 2011 and the Expenditure(as % of GDP) in Cuba in 2012?
Your answer should be compact. -2.85. What is the difference between the Expenditure(as % of GDP) of Andorra in 2011 and the Expenditure(as % of GDP) of Brunei Darussalam in 2012?
Ensure brevity in your answer.  5.21. What is the difference between the Expenditure(as % of GDP) in Andorra in 2011 and the Expenditure(as % of GDP) in Cuba in 2012?
Your answer should be very brief. -1.08. What is the difference between the Expenditure(as % of GDP) of Brunei Darussalam in 2011 and the Expenditure(as % of GDP) of Cuba in 2012?
Offer a very short reply. -6.34. What is the average Expenditure(as % of GDP) in Sub-Saharan Africa (all income levels) per year?
Give a very brief answer. 5.89. What is the average Expenditure(as % of GDP) in Andorra per year?
Your response must be concise. 6.64. What is the average Expenditure(as % of GDP) in Brunei Darussalam per year?
Your answer should be compact. 2.43. What is the average Expenditure(as % of GDP) in Cuba per year?
Make the answer very short. 9.81. In the year 2005, what is the difference between the Expenditure(as % of GDP) in Sub-Saharan Africa (all income levels) and Expenditure(as % of GDP) in Andorra?
Your answer should be very brief. 0.5. In the year 2005, what is the difference between the Expenditure(as % of GDP) in Sub-Saharan Africa (all income levels) and Expenditure(as % of GDP) in Brunei Darussalam?
Your response must be concise. 3.66. In the year 2005, what is the difference between the Expenditure(as % of GDP) in Sub-Saharan Africa (all income levels) and Expenditure(as % of GDP) in Cuba?
Give a very brief answer. -1.83. In the year 2005, what is the difference between the Expenditure(as % of GDP) in Andorra and Expenditure(as % of GDP) in Brunei Darussalam?
Make the answer very short. 3.16. In the year 2005, what is the difference between the Expenditure(as % of GDP) of Andorra and Expenditure(as % of GDP) of Cuba?
Your answer should be compact. -2.33. In the year 2005, what is the difference between the Expenditure(as % of GDP) of Brunei Darussalam and Expenditure(as % of GDP) of Cuba?
Provide a succinct answer. -5.49. In the year 2006, what is the difference between the Expenditure(as % of GDP) in Sub-Saharan Africa (all income levels) and Expenditure(as % of GDP) in Andorra?
Keep it short and to the point. 0.01. In the year 2006, what is the difference between the Expenditure(as % of GDP) of Sub-Saharan Africa (all income levels) and Expenditure(as % of GDP) of Brunei Darussalam?
Provide a short and direct response. 3.78. In the year 2006, what is the difference between the Expenditure(as % of GDP) in Sub-Saharan Africa (all income levels) and Expenditure(as % of GDP) in Cuba?
Ensure brevity in your answer.  -1.67. In the year 2006, what is the difference between the Expenditure(as % of GDP) of Andorra and Expenditure(as % of GDP) of Brunei Darussalam?
Provide a short and direct response. 3.77. In the year 2006, what is the difference between the Expenditure(as % of GDP) in Andorra and Expenditure(as % of GDP) in Cuba?
Provide a short and direct response. -1.67. In the year 2006, what is the difference between the Expenditure(as % of GDP) of Brunei Darussalam and Expenditure(as % of GDP) of Cuba?
Your answer should be compact. -5.45. In the year 2007, what is the difference between the Expenditure(as % of GDP) of Sub-Saharan Africa (all income levels) and Expenditure(as % of GDP) of Andorra?
Give a very brief answer. -0.28. In the year 2007, what is the difference between the Expenditure(as % of GDP) in Sub-Saharan Africa (all income levels) and Expenditure(as % of GDP) in Brunei Darussalam?
Offer a very short reply. 3.52. In the year 2007, what is the difference between the Expenditure(as % of GDP) of Sub-Saharan Africa (all income levels) and Expenditure(as % of GDP) of Cuba?
Provide a short and direct response. -4.6. In the year 2007, what is the difference between the Expenditure(as % of GDP) in Andorra and Expenditure(as % of GDP) in Brunei Darussalam?
Provide a short and direct response. 3.8. In the year 2007, what is the difference between the Expenditure(as % of GDP) in Andorra and Expenditure(as % of GDP) in Cuba?
Give a very brief answer. -4.32. In the year 2007, what is the difference between the Expenditure(as % of GDP) of Brunei Darussalam and Expenditure(as % of GDP) of Cuba?
Your answer should be very brief. -8.12. In the year 2008, what is the difference between the Expenditure(as % of GDP) of Sub-Saharan Africa (all income levels) and Expenditure(as % of GDP) of Andorra?
Offer a terse response. -0.47. In the year 2008, what is the difference between the Expenditure(as % of GDP) of Sub-Saharan Africa (all income levels) and Expenditure(as % of GDP) of Brunei Darussalam?
Give a very brief answer. 3.42. In the year 2008, what is the difference between the Expenditure(as % of GDP) in Sub-Saharan Africa (all income levels) and Expenditure(as % of GDP) in Cuba?
Offer a very short reply. -5.16. In the year 2008, what is the difference between the Expenditure(as % of GDP) in Andorra and Expenditure(as % of GDP) in Brunei Darussalam?
Provide a succinct answer. 3.88. In the year 2008, what is the difference between the Expenditure(as % of GDP) in Andorra and Expenditure(as % of GDP) in Cuba?
Your answer should be very brief. -4.7. In the year 2008, what is the difference between the Expenditure(as % of GDP) in Brunei Darussalam and Expenditure(as % of GDP) in Cuba?
Keep it short and to the point. -8.58. In the year 2009, what is the difference between the Expenditure(as % of GDP) of Sub-Saharan Africa (all income levels) and Expenditure(as % of GDP) of Andorra?
Provide a succinct answer. 0.17. In the year 2009, what is the difference between the Expenditure(as % of GDP) of Sub-Saharan Africa (all income levels) and Expenditure(as % of GDP) of Brunei Darussalam?
Your answer should be very brief. 3.43. In the year 2009, what is the difference between the Expenditure(as % of GDP) of Sub-Saharan Africa (all income levels) and Expenditure(as % of GDP) of Cuba?
Keep it short and to the point. -5.5. In the year 2009, what is the difference between the Expenditure(as % of GDP) of Andorra and Expenditure(as % of GDP) of Brunei Darussalam?
Ensure brevity in your answer.  3.26. In the year 2009, what is the difference between the Expenditure(as % of GDP) of Andorra and Expenditure(as % of GDP) of Cuba?
Provide a short and direct response. -5.67. In the year 2009, what is the difference between the Expenditure(as % of GDP) of Brunei Darussalam and Expenditure(as % of GDP) of Cuba?
Ensure brevity in your answer.  -8.93. In the year 2010, what is the difference between the Expenditure(as % of GDP) in Sub-Saharan Africa (all income levels) and Expenditure(as % of GDP) in Andorra?
Make the answer very short. -1.49. In the year 2010, what is the difference between the Expenditure(as % of GDP) of Sub-Saharan Africa (all income levels) and Expenditure(as % of GDP) of Brunei Darussalam?
Provide a short and direct response. 3.06. In the year 2010, what is the difference between the Expenditure(as % of GDP) in Sub-Saharan Africa (all income levels) and Expenditure(as % of GDP) in Cuba?
Your answer should be very brief. -4.77. In the year 2010, what is the difference between the Expenditure(as % of GDP) of Andorra and Expenditure(as % of GDP) of Brunei Darussalam?
Your response must be concise. 4.55. In the year 2010, what is the difference between the Expenditure(as % of GDP) of Andorra and Expenditure(as % of GDP) of Cuba?
Your answer should be very brief. -3.29. In the year 2010, what is the difference between the Expenditure(as % of GDP) in Brunei Darussalam and Expenditure(as % of GDP) in Cuba?
Provide a succinct answer. -7.83. In the year 2011, what is the difference between the Expenditure(as % of GDP) in Sub-Saharan Africa (all income levels) and Expenditure(as % of GDP) in Andorra?
Offer a terse response. -1.77. In the year 2011, what is the difference between the Expenditure(as % of GDP) in Sub-Saharan Africa (all income levels) and Expenditure(as % of GDP) in Brunei Darussalam?
Give a very brief answer. 3.5. In the year 2011, what is the difference between the Expenditure(as % of GDP) of Sub-Saharan Africa (all income levels) and Expenditure(as % of GDP) of Cuba?
Your answer should be very brief. -4.85. In the year 2011, what is the difference between the Expenditure(as % of GDP) in Andorra and Expenditure(as % of GDP) in Brunei Darussalam?
Your response must be concise. 5.27. In the year 2011, what is the difference between the Expenditure(as % of GDP) in Andorra and Expenditure(as % of GDP) in Cuba?
Offer a terse response. -3.08. In the year 2011, what is the difference between the Expenditure(as % of GDP) of Brunei Darussalam and Expenditure(as % of GDP) of Cuba?
Give a very brief answer. -8.35. In the year 2012, what is the difference between the Expenditure(as % of GDP) of Sub-Saharan Africa (all income levels) and Expenditure(as % of GDP) of Andorra?
Your response must be concise. -2.68. In the year 2012, what is the difference between the Expenditure(as % of GDP) in Sub-Saharan Africa (all income levels) and Expenditure(as % of GDP) in Brunei Darussalam?
Ensure brevity in your answer.  3.32. In the year 2012, what is the difference between the Expenditure(as % of GDP) of Sub-Saharan Africa (all income levels) and Expenditure(as % of GDP) of Cuba?
Ensure brevity in your answer.  -2.97. In the year 2012, what is the difference between the Expenditure(as % of GDP) of Andorra and Expenditure(as % of GDP) of Brunei Darussalam?
Offer a very short reply. 6. In the year 2012, what is the difference between the Expenditure(as % of GDP) in Andorra and Expenditure(as % of GDP) in Cuba?
Your answer should be very brief. -0.29. In the year 2012, what is the difference between the Expenditure(as % of GDP) of Brunei Darussalam and Expenditure(as % of GDP) of Cuba?
Keep it short and to the point. -6.29. What is the ratio of the Expenditure(as % of GDP) in Sub-Saharan Africa (all income levels) in 2005 to that in 2006?
Ensure brevity in your answer.  1.04. What is the ratio of the Expenditure(as % of GDP) in Andorra in 2005 to that in 2006?
Ensure brevity in your answer.  0.96. What is the ratio of the Expenditure(as % of GDP) of Brunei Darussalam in 2005 to that in 2006?
Your response must be concise. 1.17. What is the ratio of the Expenditure(as % of GDP) of Cuba in 2005 to that in 2006?
Keep it short and to the point. 1.05. What is the ratio of the Expenditure(as % of GDP) in Sub-Saharan Africa (all income levels) in 2005 to that in 2007?
Offer a very short reply. 1.07. What is the ratio of the Expenditure(as % of GDP) of Andorra in 2005 to that in 2007?
Ensure brevity in your answer.  0.94. What is the ratio of the Expenditure(as % of GDP) in Brunei Darussalam in 2005 to that in 2007?
Keep it short and to the point. 1.13. What is the ratio of the Expenditure(as % of GDP) of Cuba in 2005 to that in 2007?
Your response must be concise. 0.78. What is the ratio of the Expenditure(as % of GDP) of Sub-Saharan Africa (all income levels) in 2005 to that in 2008?
Your response must be concise. 1.11. What is the ratio of the Expenditure(as % of GDP) of Andorra in 2005 to that in 2008?
Give a very brief answer. 0.94. What is the ratio of the Expenditure(as % of GDP) of Brunei Darussalam in 2005 to that in 2008?
Your answer should be very brief. 1.17. What is the ratio of the Expenditure(as % of GDP) in Cuba in 2005 to that in 2008?
Provide a short and direct response. 0.75. What is the ratio of the Expenditure(as % of GDP) of Andorra in 2005 to that in 2009?
Make the answer very short. 0.95. What is the ratio of the Expenditure(as % of GDP) in Brunei Darussalam in 2005 to that in 2009?
Offer a terse response. 0.92. What is the ratio of the Expenditure(as % of GDP) of Cuba in 2005 to that in 2009?
Make the answer very short. 0.69. What is the ratio of the Expenditure(as % of GDP) in Sub-Saharan Africa (all income levels) in 2005 to that in 2010?
Offer a very short reply. 1.08. What is the ratio of the Expenditure(as % of GDP) in Andorra in 2005 to that in 2010?
Offer a terse response. 0.79. What is the ratio of the Expenditure(as % of GDP) in Brunei Darussalam in 2005 to that in 2010?
Make the answer very short. 0.95. What is the ratio of the Expenditure(as % of GDP) in Cuba in 2005 to that in 2010?
Your answer should be compact. 0.76. What is the ratio of the Expenditure(as % of GDP) in Sub-Saharan Africa (all income levels) in 2005 to that in 2011?
Ensure brevity in your answer.  1.09. What is the ratio of the Expenditure(as % of GDP) in Andorra in 2005 to that in 2011?
Provide a short and direct response. 0.77. What is the ratio of the Expenditure(as % of GDP) in Brunei Darussalam in 2005 to that in 2011?
Keep it short and to the point. 1.15. What is the ratio of the Expenditure(as % of GDP) of Cuba in 2005 to that in 2011?
Provide a succinct answer. 0.76. What is the ratio of the Expenditure(as % of GDP) of Sub-Saharan Africa (all income levels) in 2005 to that in 2012?
Offer a terse response. 1.11. What is the ratio of the Expenditure(as % of GDP) of Andorra in 2005 to that in 2012?
Provide a short and direct response. 0.69. What is the ratio of the Expenditure(as % of GDP) of Brunei Darussalam in 2005 to that in 2012?
Your answer should be very brief. 1.13. What is the ratio of the Expenditure(as % of GDP) of Cuba in 2005 to that in 2012?
Give a very brief answer. 0.94. What is the ratio of the Expenditure(as % of GDP) of Sub-Saharan Africa (all income levels) in 2006 to that in 2007?
Provide a short and direct response. 1.03. What is the ratio of the Expenditure(as % of GDP) in Andorra in 2006 to that in 2007?
Keep it short and to the point. 0.98. What is the ratio of the Expenditure(as % of GDP) in Brunei Darussalam in 2006 to that in 2007?
Offer a very short reply. 0.97. What is the ratio of the Expenditure(as % of GDP) in Cuba in 2006 to that in 2007?
Offer a very short reply. 0.74. What is the ratio of the Expenditure(as % of GDP) of Sub-Saharan Africa (all income levels) in 2006 to that in 2008?
Your answer should be very brief. 1.07. What is the ratio of the Expenditure(as % of GDP) in Andorra in 2006 to that in 2008?
Offer a terse response. 0.98. What is the ratio of the Expenditure(as % of GDP) of Brunei Darussalam in 2006 to that in 2008?
Your answer should be very brief. 1. What is the ratio of the Expenditure(as % of GDP) in Cuba in 2006 to that in 2008?
Keep it short and to the point. 0.71. What is the ratio of the Expenditure(as % of GDP) of Sub-Saharan Africa (all income levels) in 2006 to that in 2009?
Your answer should be compact. 0.96. What is the ratio of the Expenditure(as % of GDP) in Andorra in 2006 to that in 2009?
Ensure brevity in your answer.  0.99. What is the ratio of the Expenditure(as % of GDP) of Brunei Darussalam in 2006 to that in 2009?
Provide a short and direct response. 0.79. What is the ratio of the Expenditure(as % of GDP) in Cuba in 2006 to that in 2009?
Your answer should be very brief. 0.65. What is the ratio of the Expenditure(as % of GDP) in Sub-Saharan Africa (all income levels) in 2006 to that in 2010?
Your answer should be compact. 1.04. What is the ratio of the Expenditure(as % of GDP) in Andorra in 2006 to that in 2010?
Your answer should be very brief. 0.82. What is the ratio of the Expenditure(as % of GDP) in Brunei Darussalam in 2006 to that in 2010?
Provide a short and direct response. 0.81. What is the ratio of the Expenditure(as % of GDP) in Cuba in 2006 to that in 2010?
Provide a short and direct response. 0.73. What is the ratio of the Expenditure(as % of GDP) of Sub-Saharan Africa (all income levels) in 2006 to that in 2011?
Keep it short and to the point. 1.05. What is the ratio of the Expenditure(as % of GDP) in Andorra in 2006 to that in 2011?
Offer a terse response. 0.8. What is the ratio of the Expenditure(as % of GDP) in Brunei Darussalam in 2006 to that in 2011?
Provide a succinct answer. 0.99. What is the ratio of the Expenditure(as % of GDP) in Cuba in 2006 to that in 2011?
Provide a succinct answer. 0.72. What is the ratio of the Expenditure(as % of GDP) of Sub-Saharan Africa (all income levels) in 2006 to that in 2012?
Your answer should be compact. 1.07. What is the ratio of the Expenditure(as % of GDP) in Andorra in 2006 to that in 2012?
Offer a terse response. 0.72. What is the ratio of the Expenditure(as % of GDP) of Brunei Darussalam in 2006 to that in 2012?
Your response must be concise. 0.97. What is the ratio of the Expenditure(as % of GDP) in Cuba in 2006 to that in 2012?
Your response must be concise. 0.89. What is the ratio of the Expenditure(as % of GDP) of Sub-Saharan Africa (all income levels) in 2007 to that in 2008?
Provide a short and direct response. 1.03. What is the ratio of the Expenditure(as % of GDP) in Brunei Darussalam in 2007 to that in 2008?
Ensure brevity in your answer.  1.04. What is the ratio of the Expenditure(as % of GDP) in Cuba in 2007 to that in 2008?
Your answer should be compact. 0.97. What is the ratio of the Expenditure(as % of GDP) of Sub-Saharan Africa (all income levels) in 2007 to that in 2009?
Provide a succinct answer. 0.93. What is the ratio of the Expenditure(as % of GDP) of Brunei Darussalam in 2007 to that in 2009?
Offer a terse response. 0.82. What is the ratio of the Expenditure(as % of GDP) of Cuba in 2007 to that in 2009?
Your answer should be compact. 0.89. What is the ratio of the Expenditure(as % of GDP) in Andorra in 2007 to that in 2010?
Your answer should be compact. 0.84. What is the ratio of the Expenditure(as % of GDP) in Brunei Darussalam in 2007 to that in 2010?
Your response must be concise. 0.84. What is the ratio of the Expenditure(as % of GDP) of Cuba in 2007 to that in 2010?
Your answer should be very brief. 0.99. What is the ratio of the Expenditure(as % of GDP) in Sub-Saharan Africa (all income levels) in 2007 to that in 2011?
Provide a succinct answer. 1.01. What is the ratio of the Expenditure(as % of GDP) of Andorra in 2007 to that in 2011?
Provide a succinct answer. 0.81. What is the ratio of the Expenditure(as % of GDP) in Brunei Darussalam in 2007 to that in 2011?
Provide a short and direct response. 1.02. What is the ratio of the Expenditure(as % of GDP) of Cuba in 2007 to that in 2011?
Make the answer very short. 0.98. What is the ratio of the Expenditure(as % of GDP) in Sub-Saharan Africa (all income levels) in 2007 to that in 2012?
Make the answer very short. 1.03. What is the ratio of the Expenditure(as % of GDP) in Andorra in 2007 to that in 2012?
Provide a short and direct response. 0.74. What is the ratio of the Expenditure(as % of GDP) of Brunei Darussalam in 2007 to that in 2012?
Offer a terse response. 1. What is the ratio of the Expenditure(as % of GDP) of Cuba in 2007 to that in 2012?
Keep it short and to the point. 1.21. What is the ratio of the Expenditure(as % of GDP) in Sub-Saharan Africa (all income levels) in 2008 to that in 2009?
Your answer should be very brief. 0.9. What is the ratio of the Expenditure(as % of GDP) of Brunei Darussalam in 2008 to that in 2009?
Your answer should be very brief. 0.79. What is the ratio of the Expenditure(as % of GDP) in Cuba in 2008 to that in 2009?
Provide a short and direct response. 0.92. What is the ratio of the Expenditure(as % of GDP) in Sub-Saharan Africa (all income levels) in 2008 to that in 2010?
Give a very brief answer. 0.97. What is the ratio of the Expenditure(as % of GDP) in Andorra in 2008 to that in 2010?
Offer a very short reply. 0.84. What is the ratio of the Expenditure(as % of GDP) of Brunei Darussalam in 2008 to that in 2010?
Keep it short and to the point. 0.81. What is the ratio of the Expenditure(as % of GDP) of Cuba in 2008 to that in 2010?
Provide a short and direct response. 1.02. What is the ratio of the Expenditure(as % of GDP) of Sub-Saharan Africa (all income levels) in 2008 to that in 2011?
Offer a very short reply. 0.98. What is the ratio of the Expenditure(as % of GDP) of Andorra in 2008 to that in 2011?
Keep it short and to the point. 0.81. What is the ratio of the Expenditure(as % of GDP) in Cuba in 2008 to that in 2011?
Provide a succinct answer. 1.02. What is the ratio of the Expenditure(as % of GDP) in Andorra in 2008 to that in 2012?
Offer a terse response. 0.73. What is the ratio of the Expenditure(as % of GDP) of Brunei Darussalam in 2008 to that in 2012?
Keep it short and to the point. 0.96. What is the ratio of the Expenditure(as % of GDP) of Cuba in 2008 to that in 2012?
Provide a succinct answer. 1.26. What is the ratio of the Expenditure(as % of GDP) in Sub-Saharan Africa (all income levels) in 2009 to that in 2010?
Your answer should be compact. 1.08. What is the ratio of the Expenditure(as % of GDP) of Andorra in 2009 to that in 2010?
Offer a very short reply. 0.83. What is the ratio of the Expenditure(as % of GDP) of Brunei Darussalam in 2009 to that in 2010?
Ensure brevity in your answer.  1.03. What is the ratio of the Expenditure(as % of GDP) in Cuba in 2009 to that in 2010?
Keep it short and to the point. 1.11. What is the ratio of the Expenditure(as % of GDP) in Sub-Saharan Africa (all income levels) in 2009 to that in 2011?
Offer a terse response. 1.09. What is the ratio of the Expenditure(as % of GDP) in Andorra in 2009 to that in 2011?
Provide a succinct answer. 0.81. What is the ratio of the Expenditure(as % of GDP) of Brunei Darussalam in 2009 to that in 2011?
Keep it short and to the point. 1.25. What is the ratio of the Expenditure(as % of GDP) of Cuba in 2009 to that in 2011?
Keep it short and to the point. 1.11. What is the ratio of the Expenditure(as % of GDP) in Andorra in 2009 to that in 2012?
Ensure brevity in your answer.  0.73. What is the ratio of the Expenditure(as % of GDP) of Brunei Darussalam in 2009 to that in 2012?
Make the answer very short. 1.22. What is the ratio of the Expenditure(as % of GDP) in Cuba in 2009 to that in 2012?
Make the answer very short. 1.37. What is the ratio of the Expenditure(as % of GDP) of Sub-Saharan Africa (all income levels) in 2010 to that in 2011?
Keep it short and to the point. 1.01. What is the ratio of the Expenditure(as % of GDP) in Andorra in 2010 to that in 2011?
Give a very brief answer. 0.97. What is the ratio of the Expenditure(as % of GDP) of Brunei Darussalam in 2010 to that in 2011?
Your answer should be compact. 1.22. What is the ratio of the Expenditure(as % of GDP) of Sub-Saharan Africa (all income levels) in 2010 to that in 2012?
Provide a succinct answer. 1.03. What is the ratio of the Expenditure(as % of GDP) in Andorra in 2010 to that in 2012?
Provide a succinct answer. 0.88. What is the ratio of the Expenditure(as % of GDP) in Brunei Darussalam in 2010 to that in 2012?
Keep it short and to the point. 1.19. What is the ratio of the Expenditure(as % of GDP) in Cuba in 2010 to that in 2012?
Your answer should be very brief. 1.23. What is the ratio of the Expenditure(as % of GDP) in Sub-Saharan Africa (all income levels) in 2011 to that in 2012?
Keep it short and to the point. 1.02. What is the ratio of the Expenditure(as % of GDP) in Andorra in 2011 to that in 2012?
Give a very brief answer. 0.9. What is the ratio of the Expenditure(as % of GDP) in Brunei Darussalam in 2011 to that in 2012?
Give a very brief answer. 0.98. What is the ratio of the Expenditure(as % of GDP) in Cuba in 2011 to that in 2012?
Your answer should be compact. 1.23. What is the difference between the highest and the second highest Expenditure(as % of GDP) of Sub-Saharan Africa (all income levels)?
Provide a short and direct response. 0. What is the difference between the highest and the second highest Expenditure(as % of GDP) of Andorra?
Offer a very short reply. 0.79. What is the difference between the highest and the second highest Expenditure(as % of GDP) of Brunei Darussalam?
Your response must be concise. 0.08. What is the difference between the highest and the second highest Expenditure(as % of GDP) in Cuba?
Make the answer very short. 0.95. What is the difference between the highest and the lowest Expenditure(as % of GDP) of Sub-Saharan Africa (all income levels)?
Your response must be concise. 0.63. What is the difference between the highest and the lowest Expenditure(as % of GDP) of Andorra?
Provide a succinct answer. 2.55. What is the difference between the highest and the lowest Expenditure(as % of GDP) of Brunei Darussalam?
Provide a short and direct response. 0.6. What is the difference between the highest and the lowest Expenditure(as % of GDP) of Cuba?
Give a very brief answer. 4.07. 